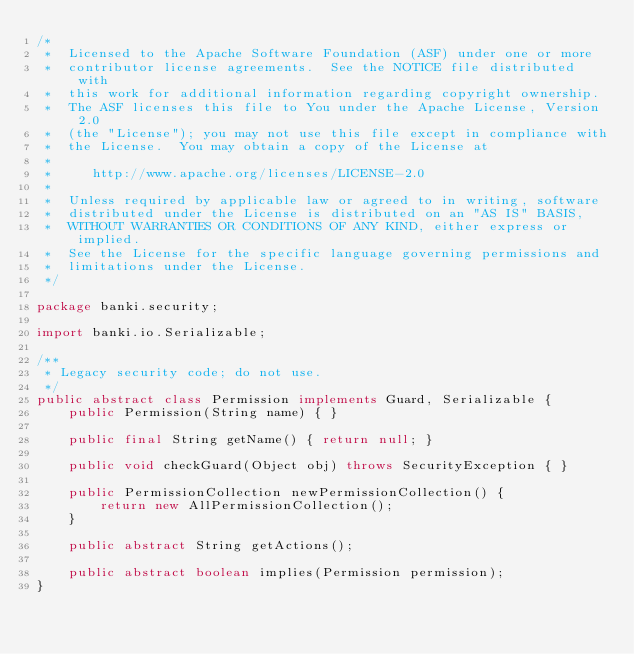Convert code to text. <code><loc_0><loc_0><loc_500><loc_500><_Java_>/*
 *  Licensed to the Apache Software Foundation (ASF) under one or more
 *  contributor license agreements.  See the NOTICE file distributed with
 *  this work for additional information regarding copyright ownership.
 *  The ASF licenses this file to You under the Apache License, Version 2.0
 *  (the "License"); you may not use this file except in compliance with
 *  the License.  You may obtain a copy of the License at
 *
 *     http://www.apache.org/licenses/LICENSE-2.0
 *
 *  Unless required by applicable law or agreed to in writing, software
 *  distributed under the License is distributed on an "AS IS" BASIS,
 *  WITHOUT WARRANTIES OR CONDITIONS OF ANY KIND, either express or implied.
 *  See the License for the specific language governing permissions and
 *  limitations under the License.
 */

package banki.security;

import banki.io.Serializable;

/**
 * Legacy security code; do not use.
 */
public abstract class Permission implements Guard, Serializable {
    public Permission(String name) { }

    public final String getName() { return null; }

    public void checkGuard(Object obj) throws SecurityException { }

    public PermissionCollection newPermissionCollection() {
        return new AllPermissionCollection();
    }

    public abstract String getActions();

    public abstract boolean implies(Permission permission);
}
</code> 